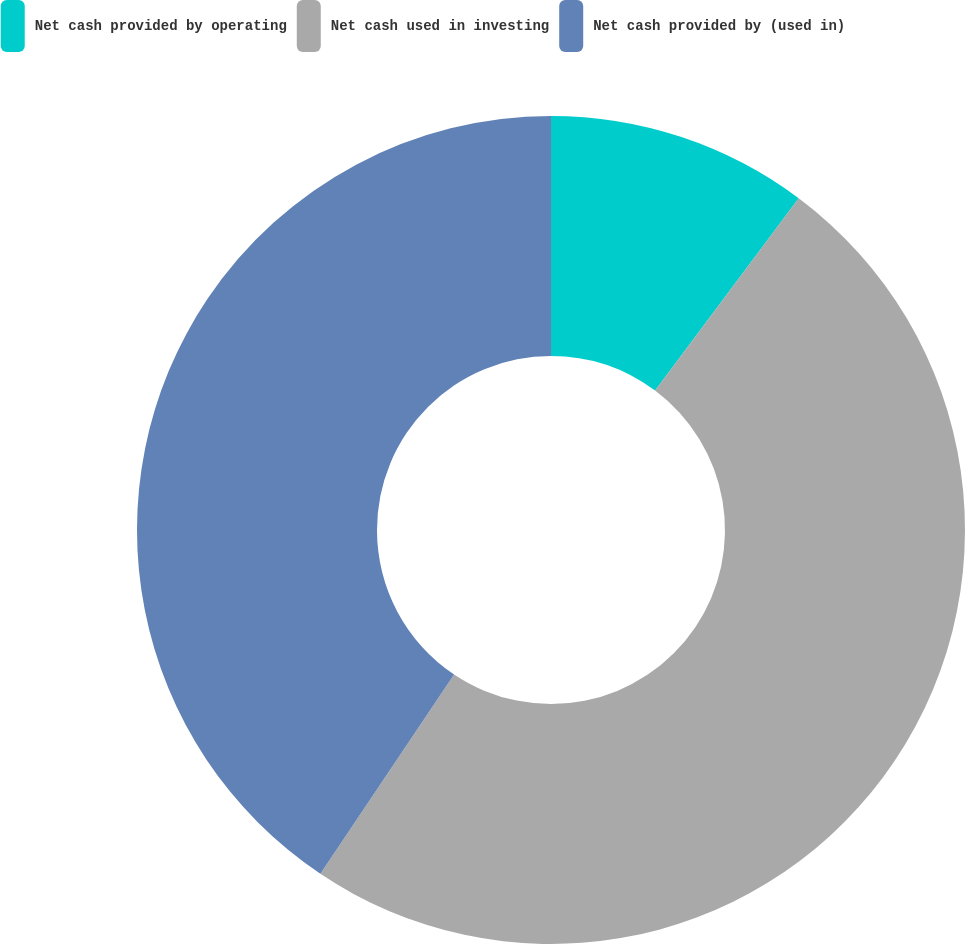Convert chart to OTSL. <chart><loc_0><loc_0><loc_500><loc_500><pie_chart><fcel>Net cash provided by operating<fcel>Net cash used in investing<fcel>Net cash provided by (used in)<nl><fcel>10.21%<fcel>49.2%<fcel>40.6%<nl></chart> 